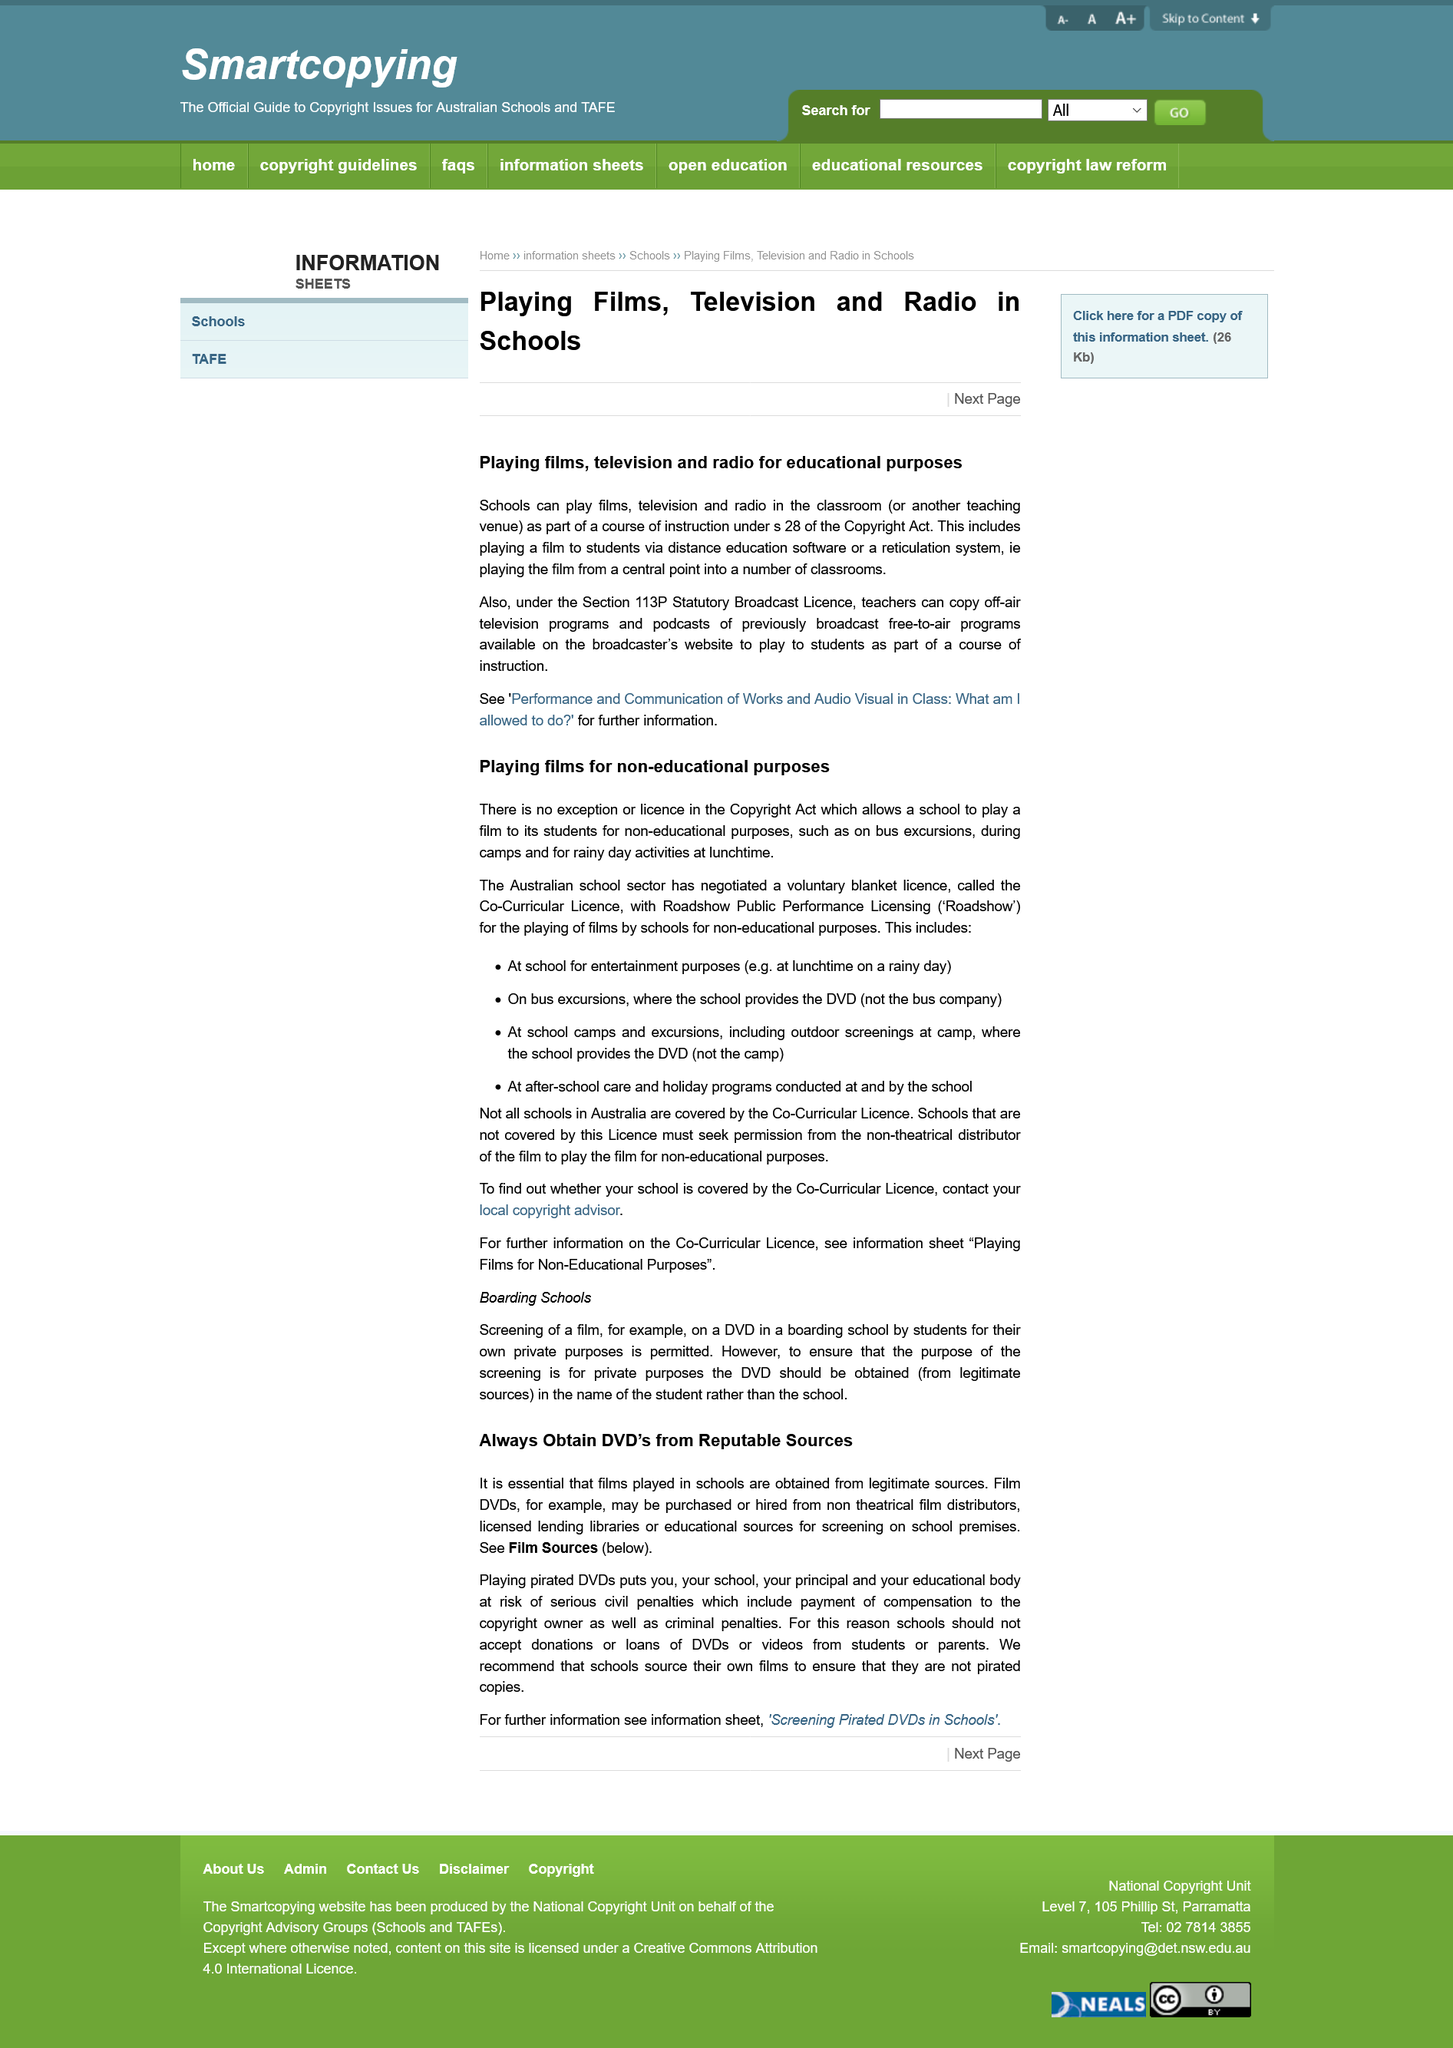Point out several critical features in this image. For educational purposes, the full title of this article is "Playing Films, Television and Radio for......". It is imperative that all films shown in schools are acquired from legitimate sources in order to ensure their authenticity and integrity. The Australian school sector has negotiated a voluntary blanket license, which is a type of agreement that allows for the use of copyrighted material without the need for individual permissions. The Copyright Act allows schools to play television and radio in the classroom under Section 28. Teachers may copy off-air television programs and podcasts of previously broadcast free-to-air programs under Section 113P of the Statutory Broadcast License. 